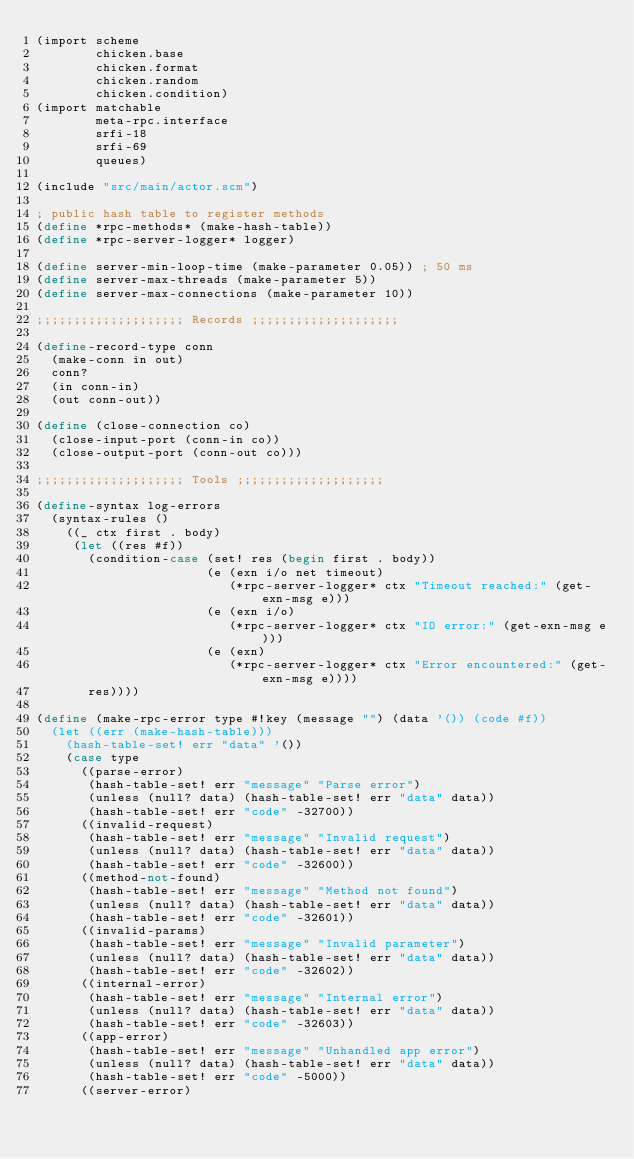Convert code to text. <code><loc_0><loc_0><loc_500><loc_500><_Scheme_>(import scheme
        chicken.base
        chicken.format
        chicken.random
        chicken.condition)
(import matchable
        meta-rpc.interface
        srfi-18
        srfi-69
        queues)

(include "src/main/actor.scm")

; public hash table to register methods
(define *rpc-methods* (make-hash-table))
(define *rpc-server-logger* logger)

(define server-min-loop-time (make-parameter 0.05)) ; 50 ms
(define server-max-threads (make-parameter 5))
(define server-max-connections (make-parameter 10))

;;;;;;;;;;;;;;;;;;;; Records ;;;;;;;;;;;;;;;;;;;;

(define-record-type conn
  (make-conn in out)
  conn?
  (in conn-in)
  (out conn-out))

(define (close-connection co)
  (close-input-port (conn-in co))
  (close-output-port (conn-out co)))

;;;;;;;;;;;;;;;;;;;; Tools ;;;;;;;;;;;;;;;;;;;;

(define-syntax log-errors
  (syntax-rules ()
    ((_ ctx first . body)
     (let ((res #f))
       (condition-case (set! res (begin first . body))
                       (e (exn i/o net timeout)
                          (*rpc-server-logger* ctx "Timeout reached:" (get-exn-msg e)))
                       (e (exn i/o)
                          (*rpc-server-logger* ctx "IO error:" (get-exn-msg e)))
                       (e (exn)
                          (*rpc-server-logger* ctx "Error encountered:" (get-exn-msg e))))
       res))))

(define (make-rpc-error type #!key (message "") (data '()) (code #f))
  (let ((err (make-hash-table)))
    (hash-table-set! err "data" '())
    (case type
      ((parse-error) 
       (hash-table-set! err "message" "Parse error")
       (unless (null? data) (hash-table-set! err "data" data))
       (hash-table-set! err "code" -32700))
      ((invalid-request)
       (hash-table-set! err "message" "Invalid request")
       (unless (null? data) (hash-table-set! err "data" data))
       (hash-table-set! err "code" -32600))
      ((method-not-found)
       (hash-table-set! err "message" "Method not found")
       (unless (null? data) (hash-table-set! err "data" data))
       (hash-table-set! err "code" -32601))
      ((invalid-params)
       (hash-table-set! err "message" "Invalid parameter")
       (unless (null? data) (hash-table-set! err "data" data))
       (hash-table-set! err "code" -32602))
      ((internal-error)
       (hash-table-set! err "message" "Internal error")
       (unless (null? data) (hash-table-set! err "data" data))
       (hash-table-set! err "code" -32603))
      ((app-error)
       (hash-table-set! err "message" "Unhandled app error")
       (unless (null? data) (hash-table-set! err "data" data))
       (hash-table-set! err "code" -5000))
      ((server-error)</code> 